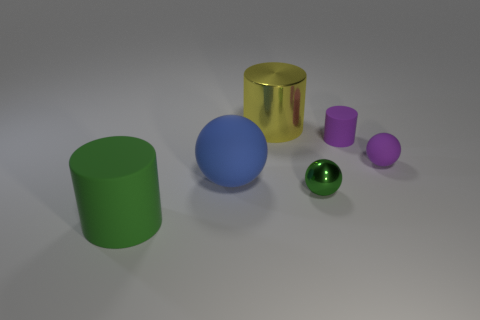Add 4 small brown rubber cylinders. How many objects exist? 10 Add 1 blue spheres. How many blue spheres are left? 2 Add 1 big metallic balls. How many big metallic balls exist? 1 Subtract 0 cyan cylinders. How many objects are left? 6 Subtract all large blue rubber things. Subtract all big blue matte things. How many objects are left? 4 